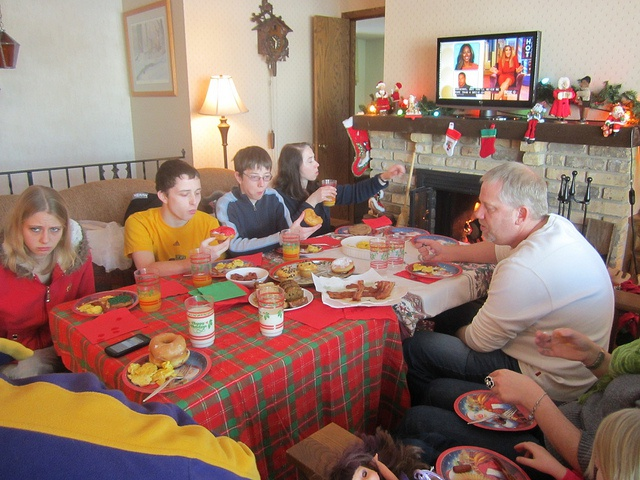Describe the objects in this image and their specific colors. I can see dining table in darkgray, brown, and tan tones, people in darkgray, lightgray, gray, and black tones, people in darkgray, gray, brown, and maroon tones, tv in darkgray, white, black, gray, and tan tones, and people in darkgray, orange, lightpink, salmon, and red tones in this image. 